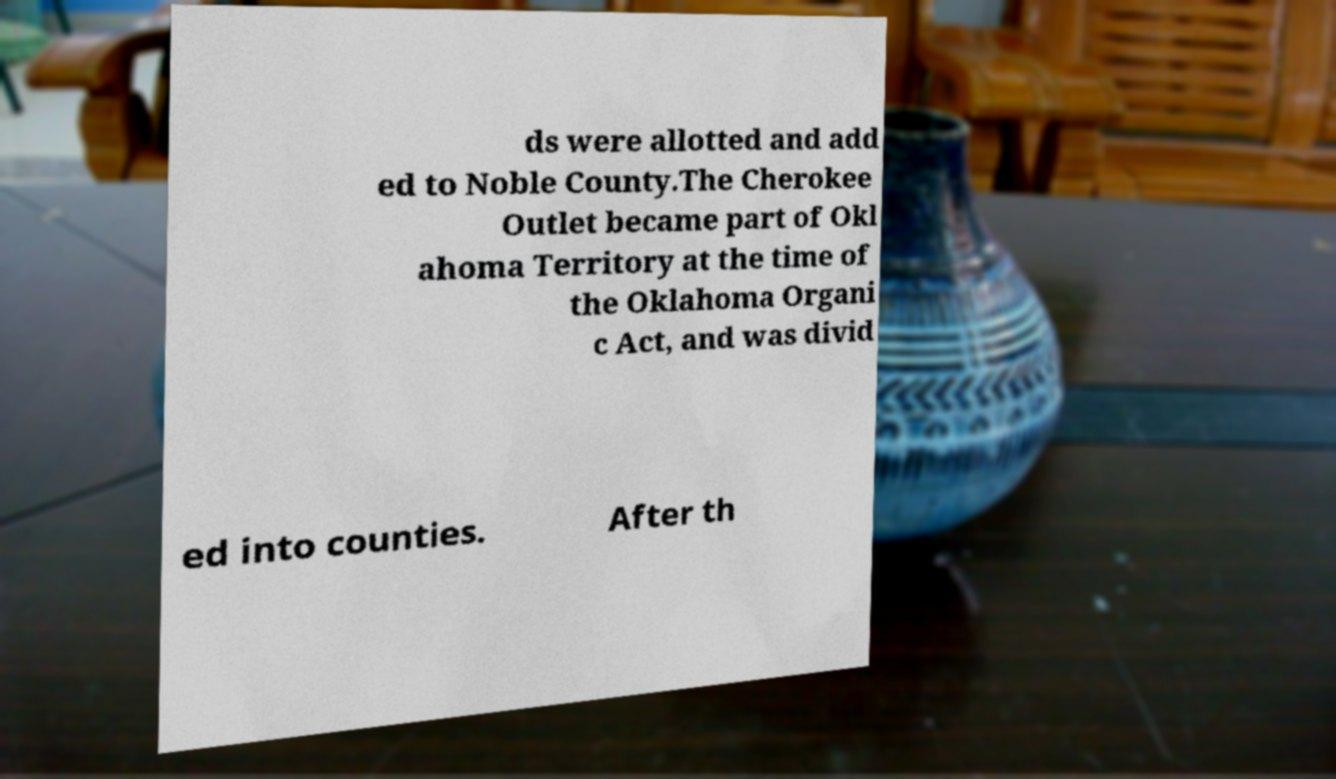Can you accurately transcribe the text from the provided image for me? ds were allotted and add ed to Noble County.The Cherokee Outlet became part of Okl ahoma Territory at the time of the Oklahoma Organi c Act, and was divid ed into counties. After th 